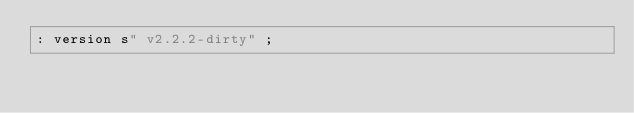<code> <loc_0><loc_0><loc_500><loc_500><_Forth_>: version s" v2.2.2-dirty" ;
</code> 